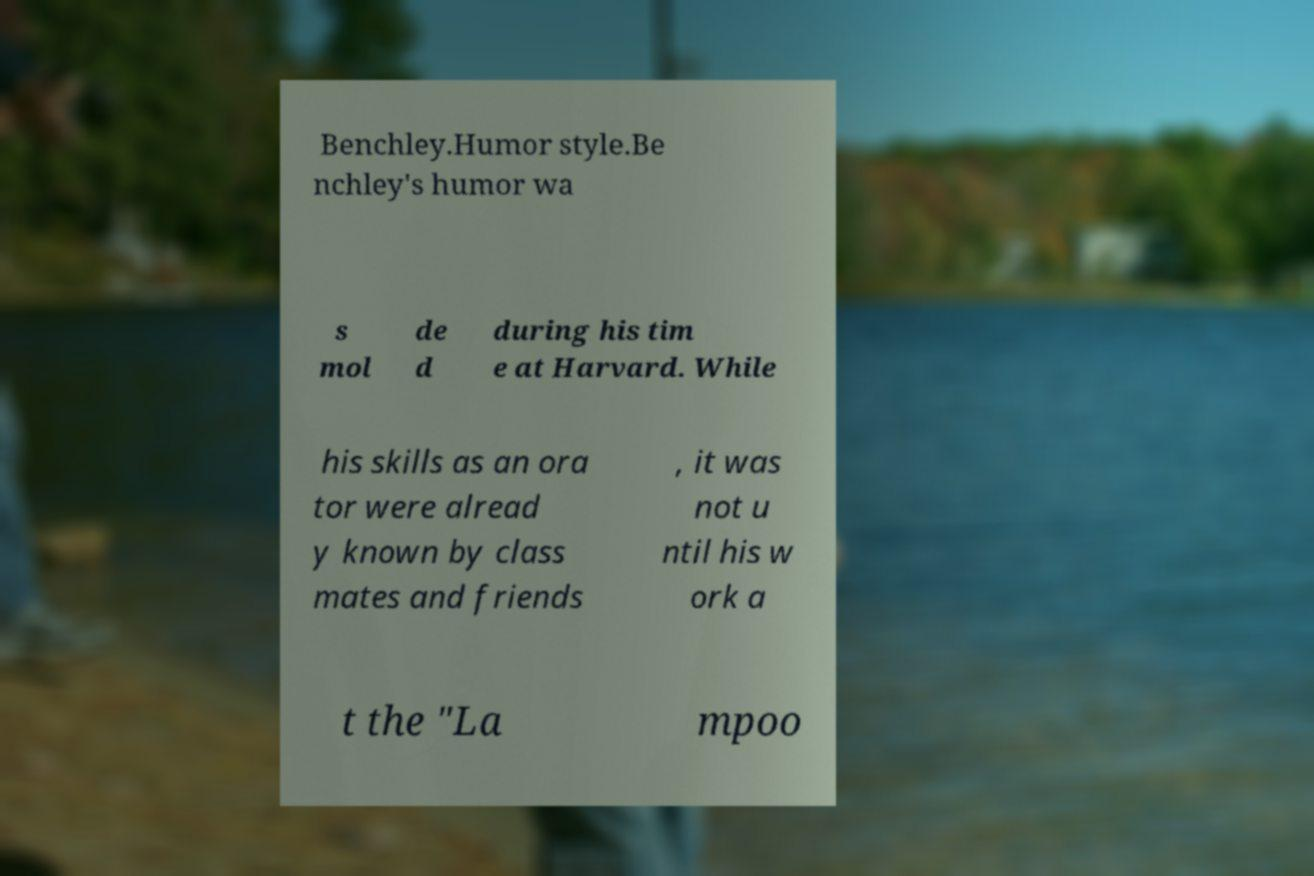Can you read and provide the text displayed in the image?This photo seems to have some interesting text. Can you extract and type it out for me? Benchley.Humor style.Be nchley's humor wa s mol de d during his tim e at Harvard. While his skills as an ora tor were alread y known by class mates and friends , it was not u ntil his w ork a t the "La mpoo 